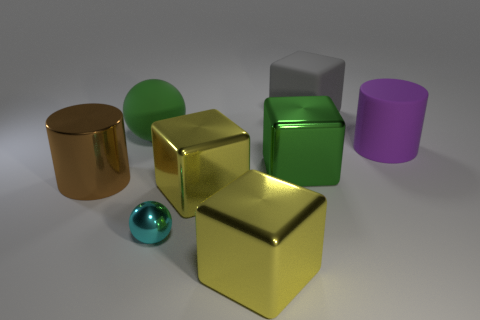What is the size of the purple matte cylinder?
Offer a terse response. Large. How many other things are the same color as the big rubber cylinder?
Offer a very short reply. 0. Does the sphere that is behind the green cube have the same material as the gray object?
Provide a short and direct response. Yes. Are there fewer big purple cylinders in front of the rubber cylinder than big metallic cylinders behind the brown metal cylinder?
Ensure brevity in your answer.  No. What number of other objects are the same material as the cyan object?
Make the answer very short. 4. There is a brown cylinder that is the same size as the gray matte thing; what is it made of?
Provide a succinct answer. Metal. Is the number of large blocks that are in front of the large ball less than the number of small shiny balls?
Keep it short and to the point. No. There is a big green object that is right of the small cyan shiny ball to the left of the yellow metallic block in front of the tiny cyan ball; what shape is it?
Your answer should be compact. Cube. There is a cylinder that is right of the large gray rubber block; how big is it?
Give a very brief answer. Large. There is a purple thing that is the same size as the gray rubber object; what is its shape?
Keep it short and to the point. Cylinder. 